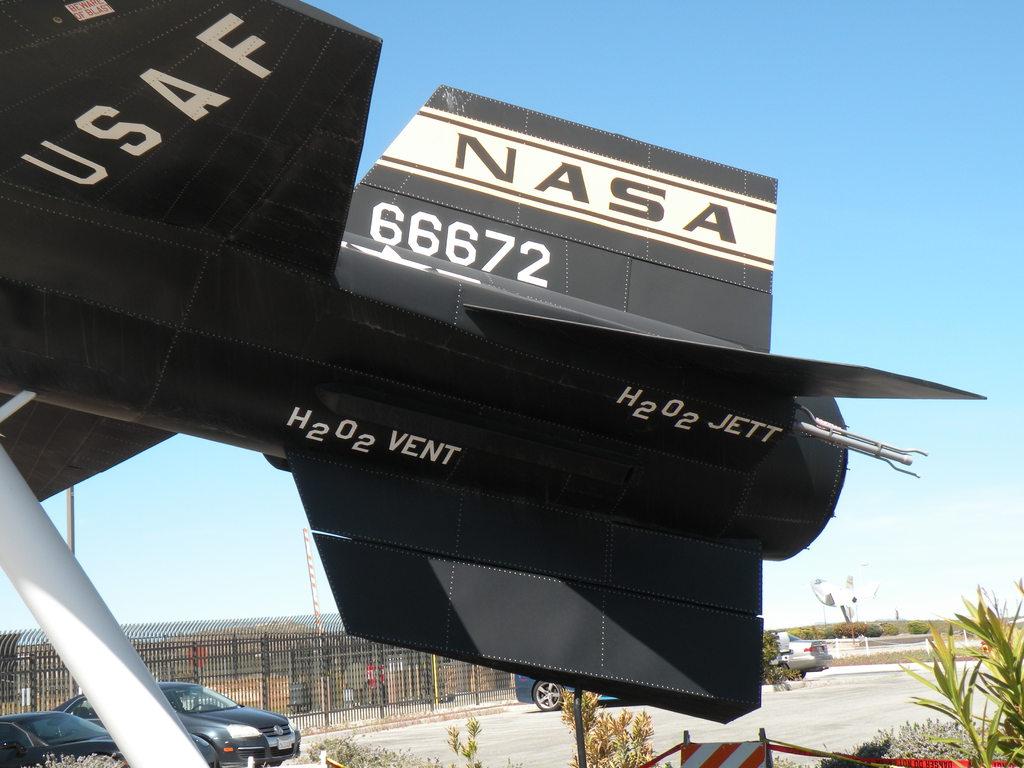What letters are in the white strip?
Keep it short and to the point. Nasa. Does nasa use h202 as fuel for their rockets?
Your response must be concise. Yes. 